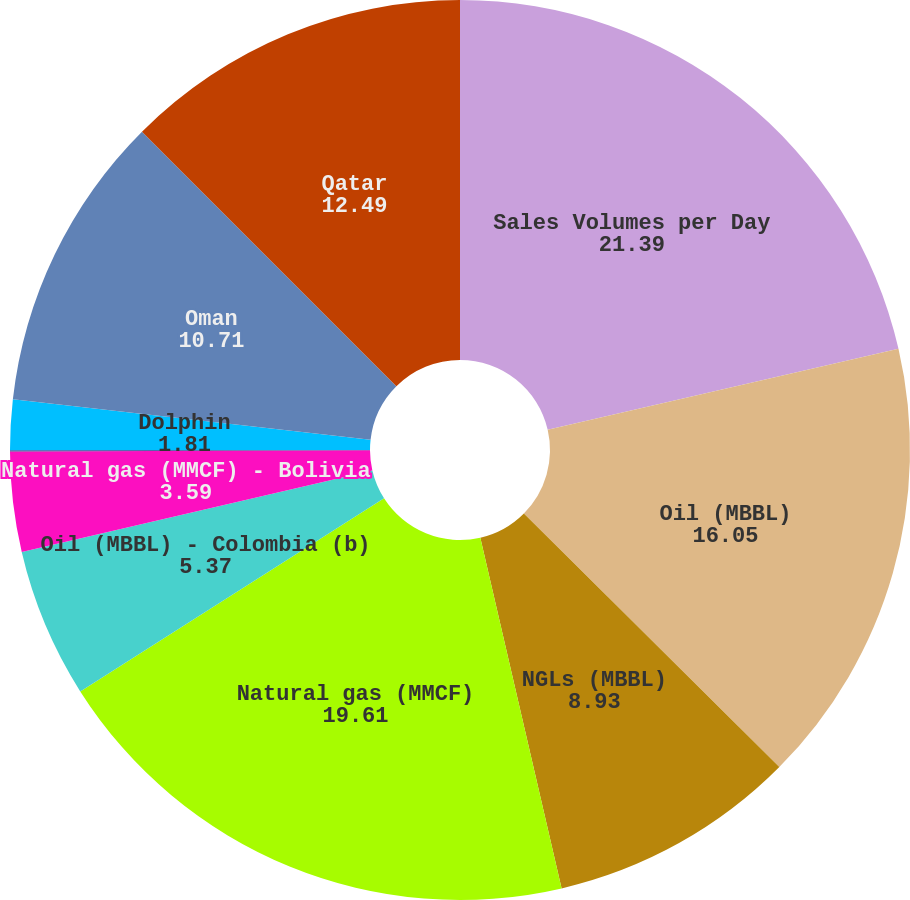Convert chart. <chart><loc_0><loc_0><loc_500><loc_500><pie_chart><fcel>Sales Volumes per Day<fcel>Oil (MBBL)<fcel>NGLs (MBBL)<fcel>Natural gas (MMCF)<fcel>Oil (MBBL) - Colombia (b)<fcel>Natural gas (MMCF) - Bolivia<fcel>Bahrain<fcel>Dolphin<fcel>Oman<fcel>Qatar<nl><fcel>21.39%<fcel>16.05%<fcel>8.93%<fcel>19.61%<fcel>5.37%<fcel>3.59%<fcel>0.04%<fcel>1.81%<fcel>10.71%<fcel>12.49%<nl></chart> 